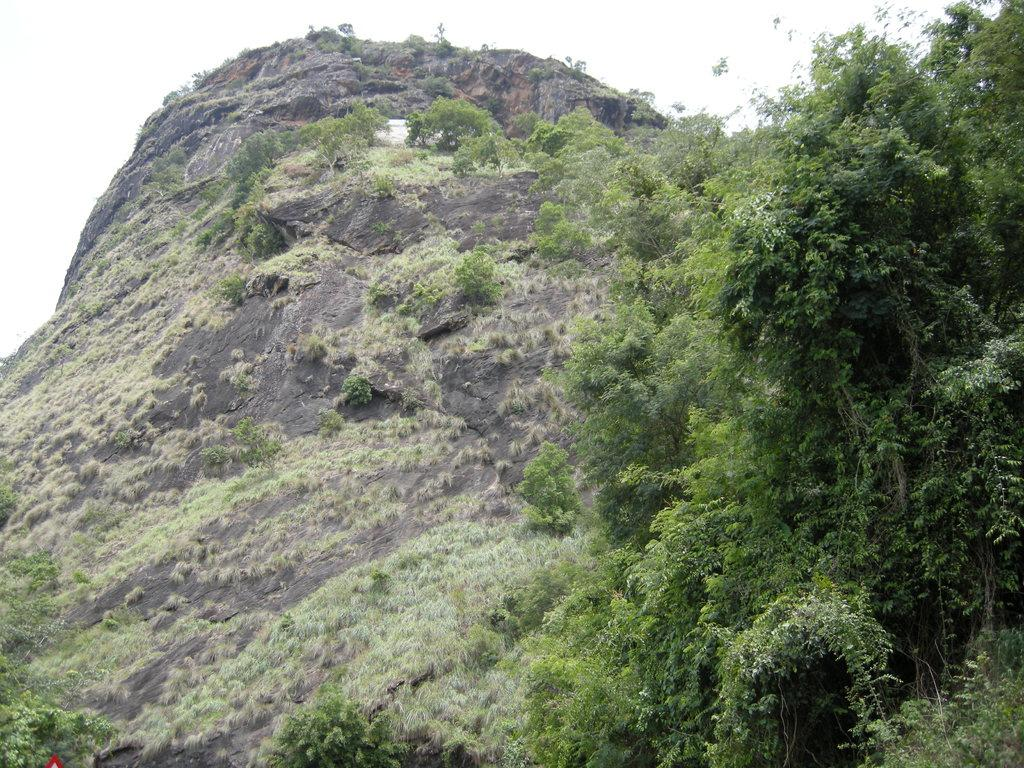What is the main geographical feature in the image? There is a hill in the image. What type of vegetation can be seen on the hill? There are trees on the hill. Where is the fork located in the image? There is no fork present in the image. What type of patch can be seen on the hill in the image? There is no patch present on the hill in the image; it only features trees. 